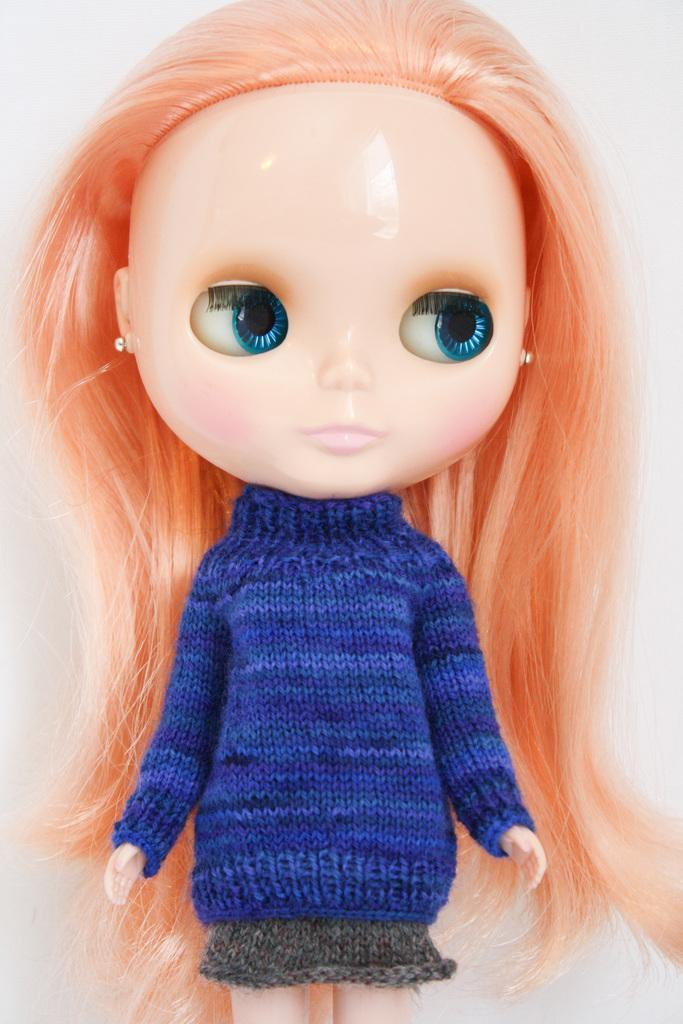What is the main subject of the image? There is a doll in the image. What is the doll wearing? The doll is wearing a blue and grey color dress. What color is the background of the image? The background of the image is white. How many fish can be seen swimming in the background of the image? There are no fish present in the image; the background is white. What type of pets are visible in the image? There are no pets visible in the image; the main subject is a doll. 